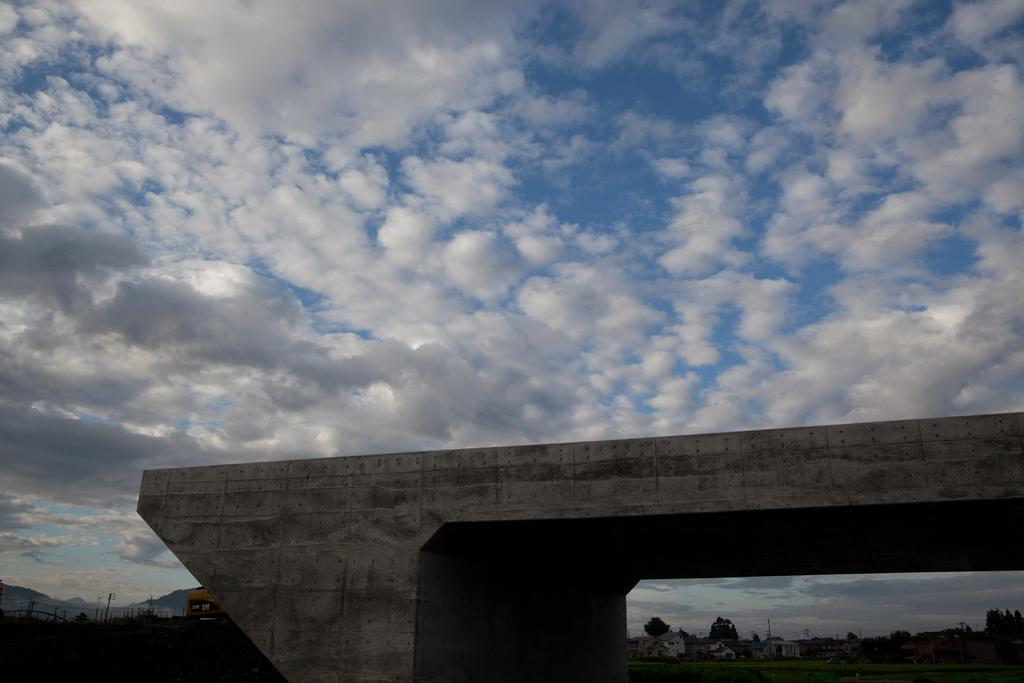What can be seen in the sky in the image? There are clouds visible in the sky in the image. What is visible in the background of the image? There are trees and buildings in the background of the image. How many spots can be seen on the clam in the image? There is no clam present in the image; it features clouds, sky, trees, and buildings. What type of town is depicted in the image? The image does not depict a town; it shows clouds, sky, trees, and buildings in the background. 